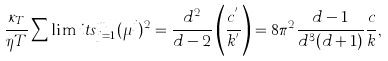<formula> <loc_0><loc_0><loc_500><loc_500>\frac { \kappa _ { T } } { \eta T } \sum \lim i t s _ { j = 1 } ^ { m } ( \mu ^ { j } ) ^ { 2 } = \frac { d ^ { 2 } } { d - 2 } \left ( \frac { c ^ { ^ { \prime } } } { k ^ { ^ { \prime } } } \right ) = 8 \pi ^ { 2 } \frac { d - 1 } { d ^ { 3 } ( d + 1 ) } \frac { c } { k } ,</formula> 